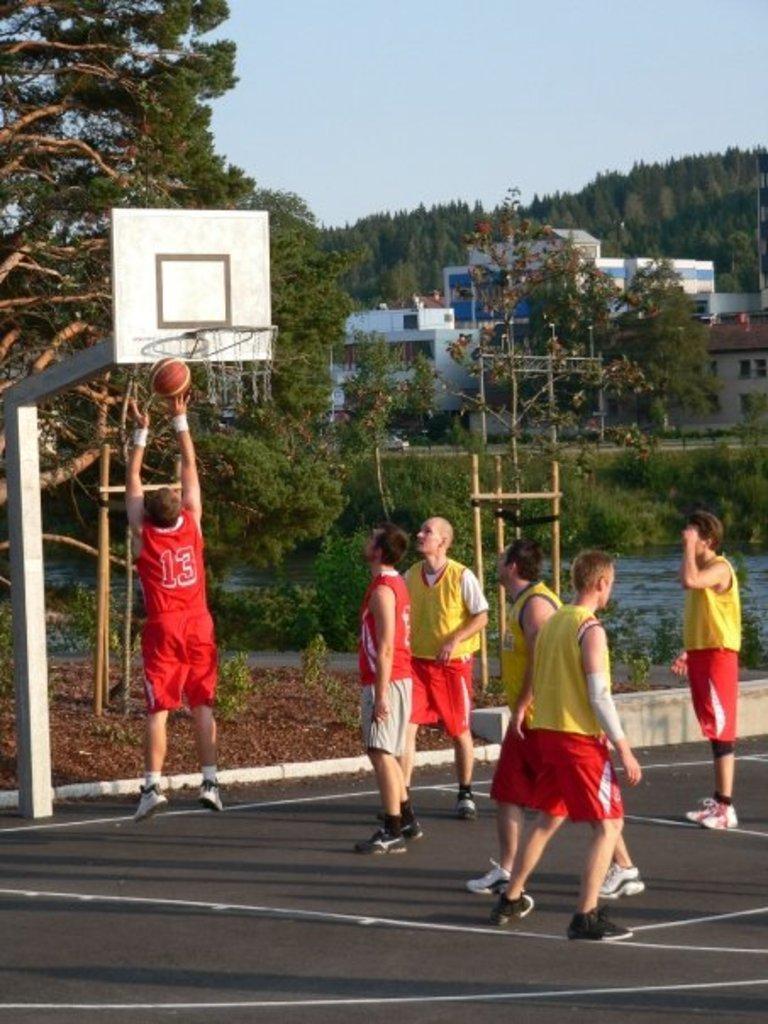Describe this image in one or two sentences. In the center of the image a group of people are standing. In the background of the image we can see the trees, building are present. On the left side of the image wallyball coat is there. At the bottom of the image ground is present. In the middle of the image water is there. At the top of the image sky is present. 